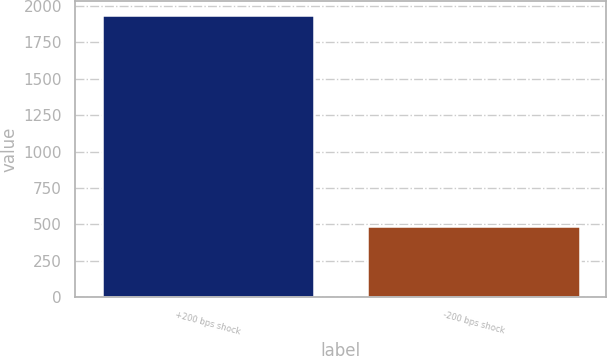Convert chart to OTSL. <chart><loc_0><loc_0><loc_500><loc_500><bar_chart><fcel>+200 bps shock<fcel>-200 bps shock<nl><fcel>1936<fcel>490<nl></chart> 